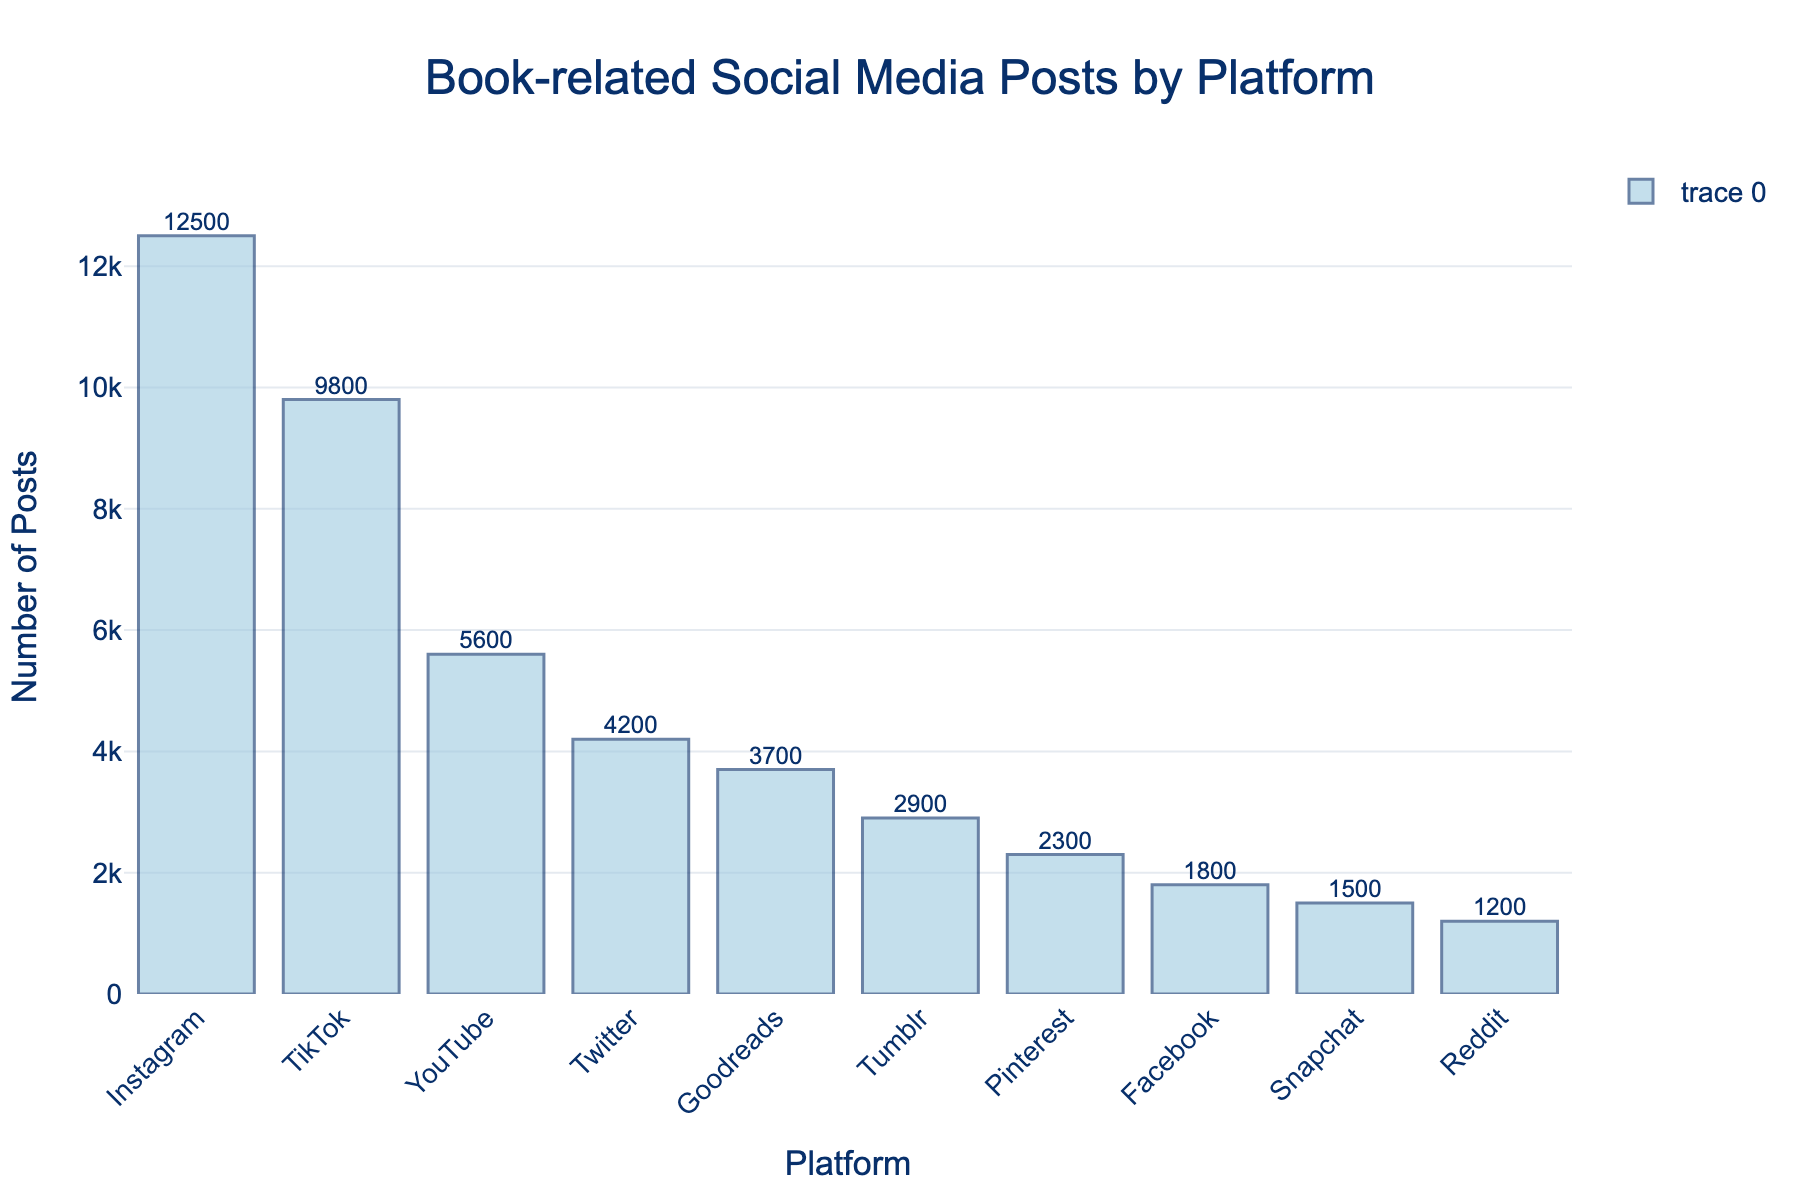What's the most popular platform for book-related posts? The tallest bar represents the platform with the highest number of posts, which is Instagram with 12,500 posts.
Answer: Instagram Which platform has fewer book-related posts: Pinterest or Tumblr? By comparing the heights of the bars for Pinterest and Tumblr, we see that Pinterest has 2,300 posts and Tumblr has 2,900 posts. Therefore, Pinterest has fewer posts.
Answer: Pinterest What’s the total number of book-related posts on Instagram and TikTok combined? Adding the number of posts from Instagram (12,500) and TikTok (9,800) gives us the total. 12,500 + 9,800 = 22,300.
Answer: 22,300 How many more posts does YouTube have than Facebook? YouTube has 5,600 posts and Facebook has 1,800 posts. The difference is 5,600 - 1,800 = 3,800.
Answer: 3,800 Rank the social media platforms from the highest to lowest number of book-related posts. The order, based on the height of the bars from highest to lowest, is: Instagram, TikTok, YouTube, Twitter, Goodreads, Tumblr, Pinterest, Facebook, Snapchat, Reddit.
Answer: Instagram, TikTok, YouTube, Twitter, Goodreads, Tumblr, Pinterest, Facebook, Snapchat, Reddit What is the average number of book-related posts per platform? The total number of posts combined is 12,500 + 9,800 + 5,600 + 4,200 + 3,700 + 2,900 + 2,300 + 1,800 + 1,500 + 1,200 = 45,500. There are 10 platforms, so the average is 45,500 / 10 = 4,550.
Answer: 4,550 Are there more total posts on Goodreads, Tumblr, and Pinterest combined than on TikTok? Summing the posts for Goodreads (3,700), Tumblr (2,900), and Pinterest (2,300) gives 3,700 + 2,900 + 2,300 = 8,900. TikTok has 9,800 posts. So, TikTok has more posts.
Answer: No What percentage of the total posts does Twitter represent? First, find the total number of posts: 45,500. Then, calculate the percentage for Twitter's 4,200 posts: (4,200 / 45,500) * 100 ≈ 9.23%.
Answer: 9.23% Which platform is exactly in the middle in terms of the number of book-related posts? Sorting the platforms by the number of posts, the middle ones are: Instagram (12,500), TikTok (9,800), YouTube (5,600), Twitter (4,200), Goodreads (3,700), Tumblr (2,900), Pinterest (2,300), Facebook (1,800), Snapchat (1,500), Reddit (1,200). The middle platform (5th position) is Goodreads with 3,700 posts.
Answer: Goodreads 